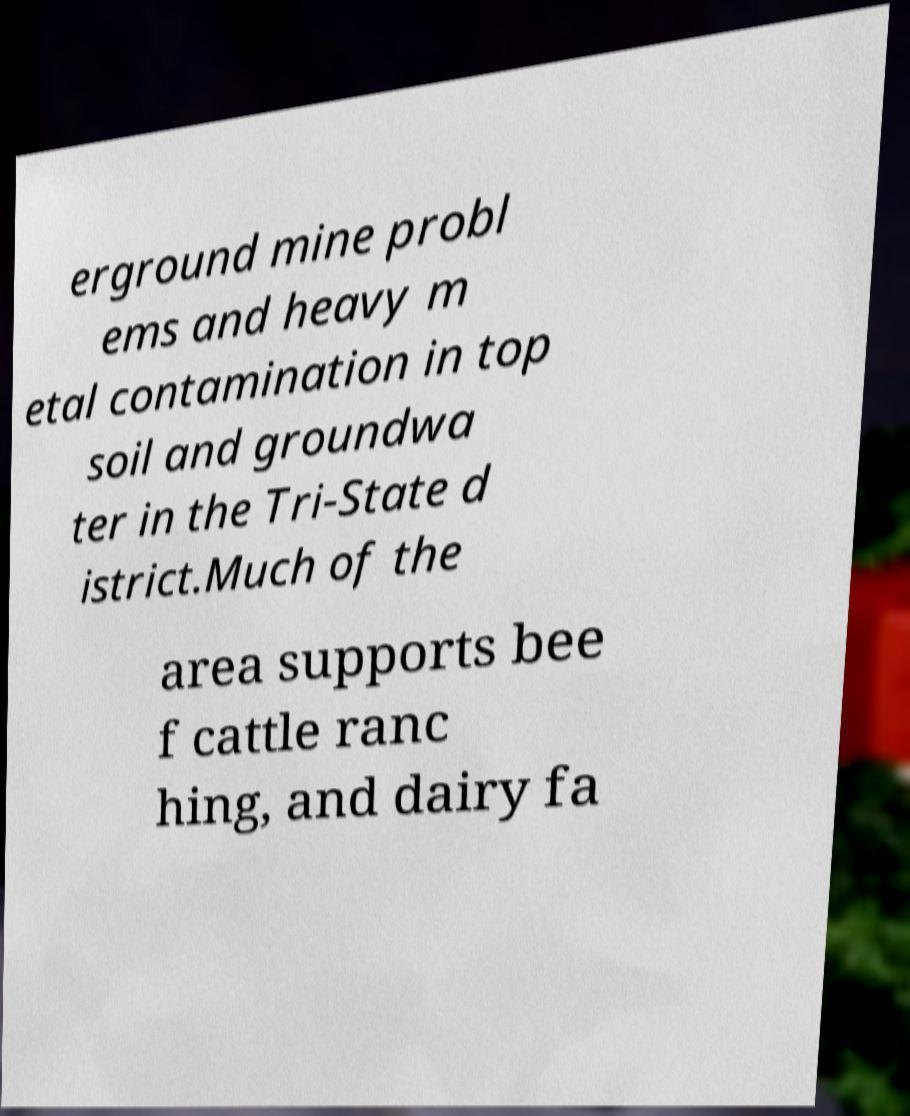For documentation purposes, I need the text within this image transcribed. Could you provide that? erground mine probl ems and heavy m etal contamination in top soil and groundwa ter in the Tri-State d istrict.Much of the area supports bee f cattle ranc hing, and dairy fa 